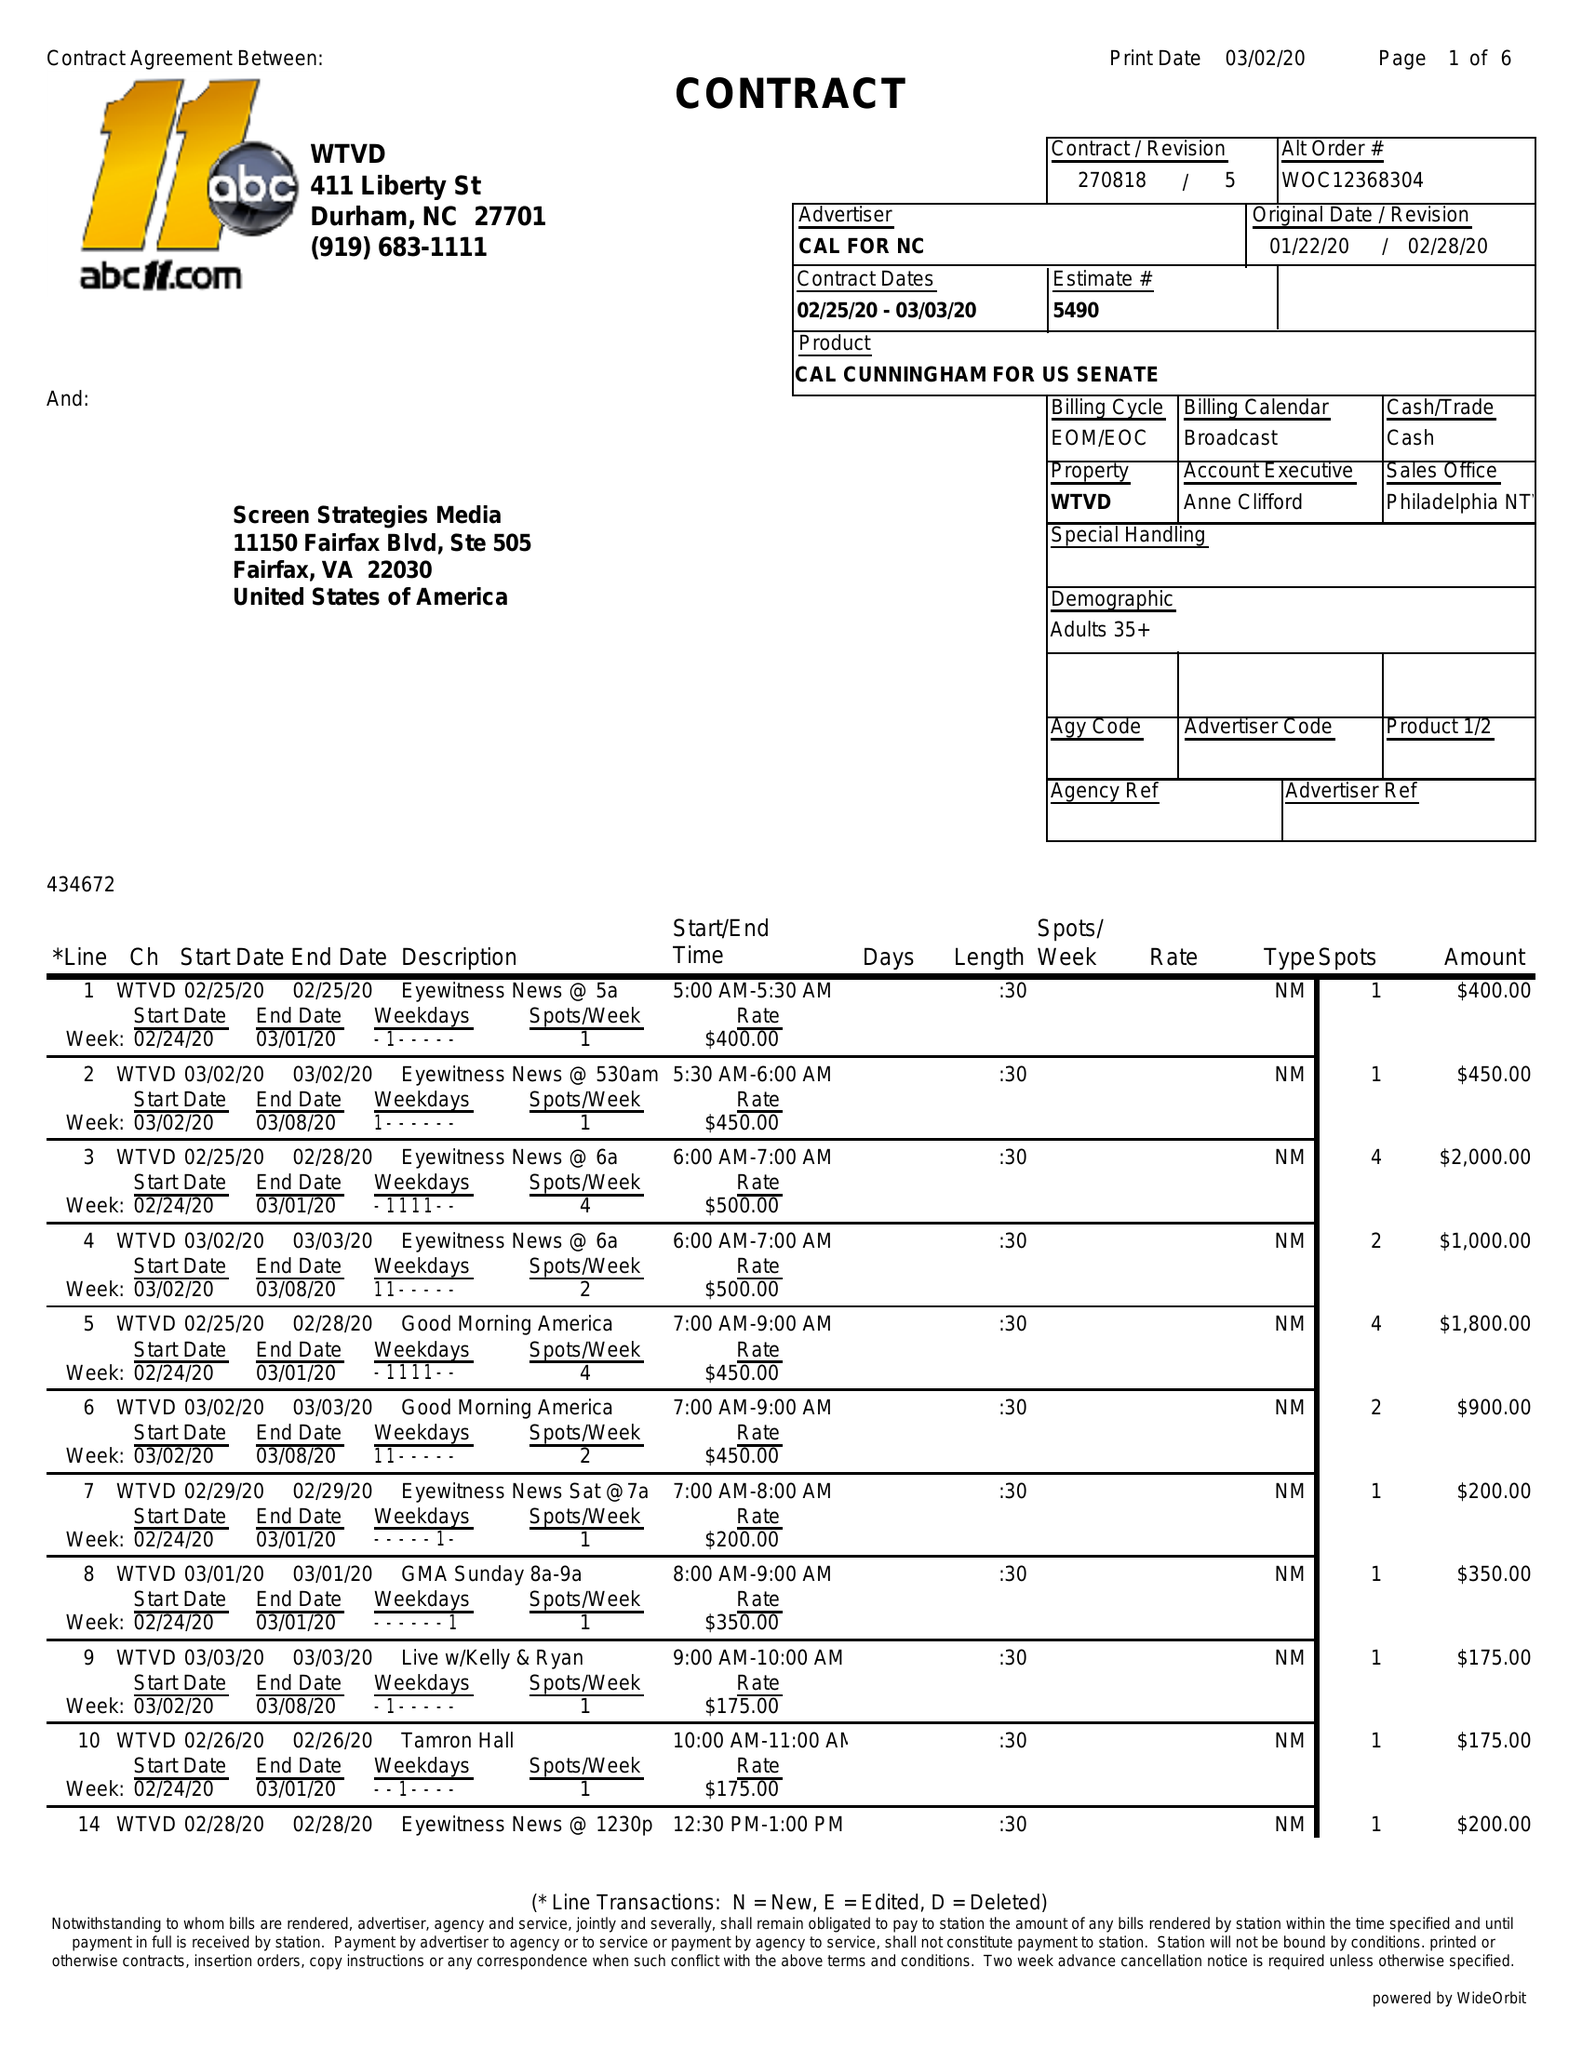What is the value for the flight_to?
Answer the question using a single word or phrase. 03/03/20 